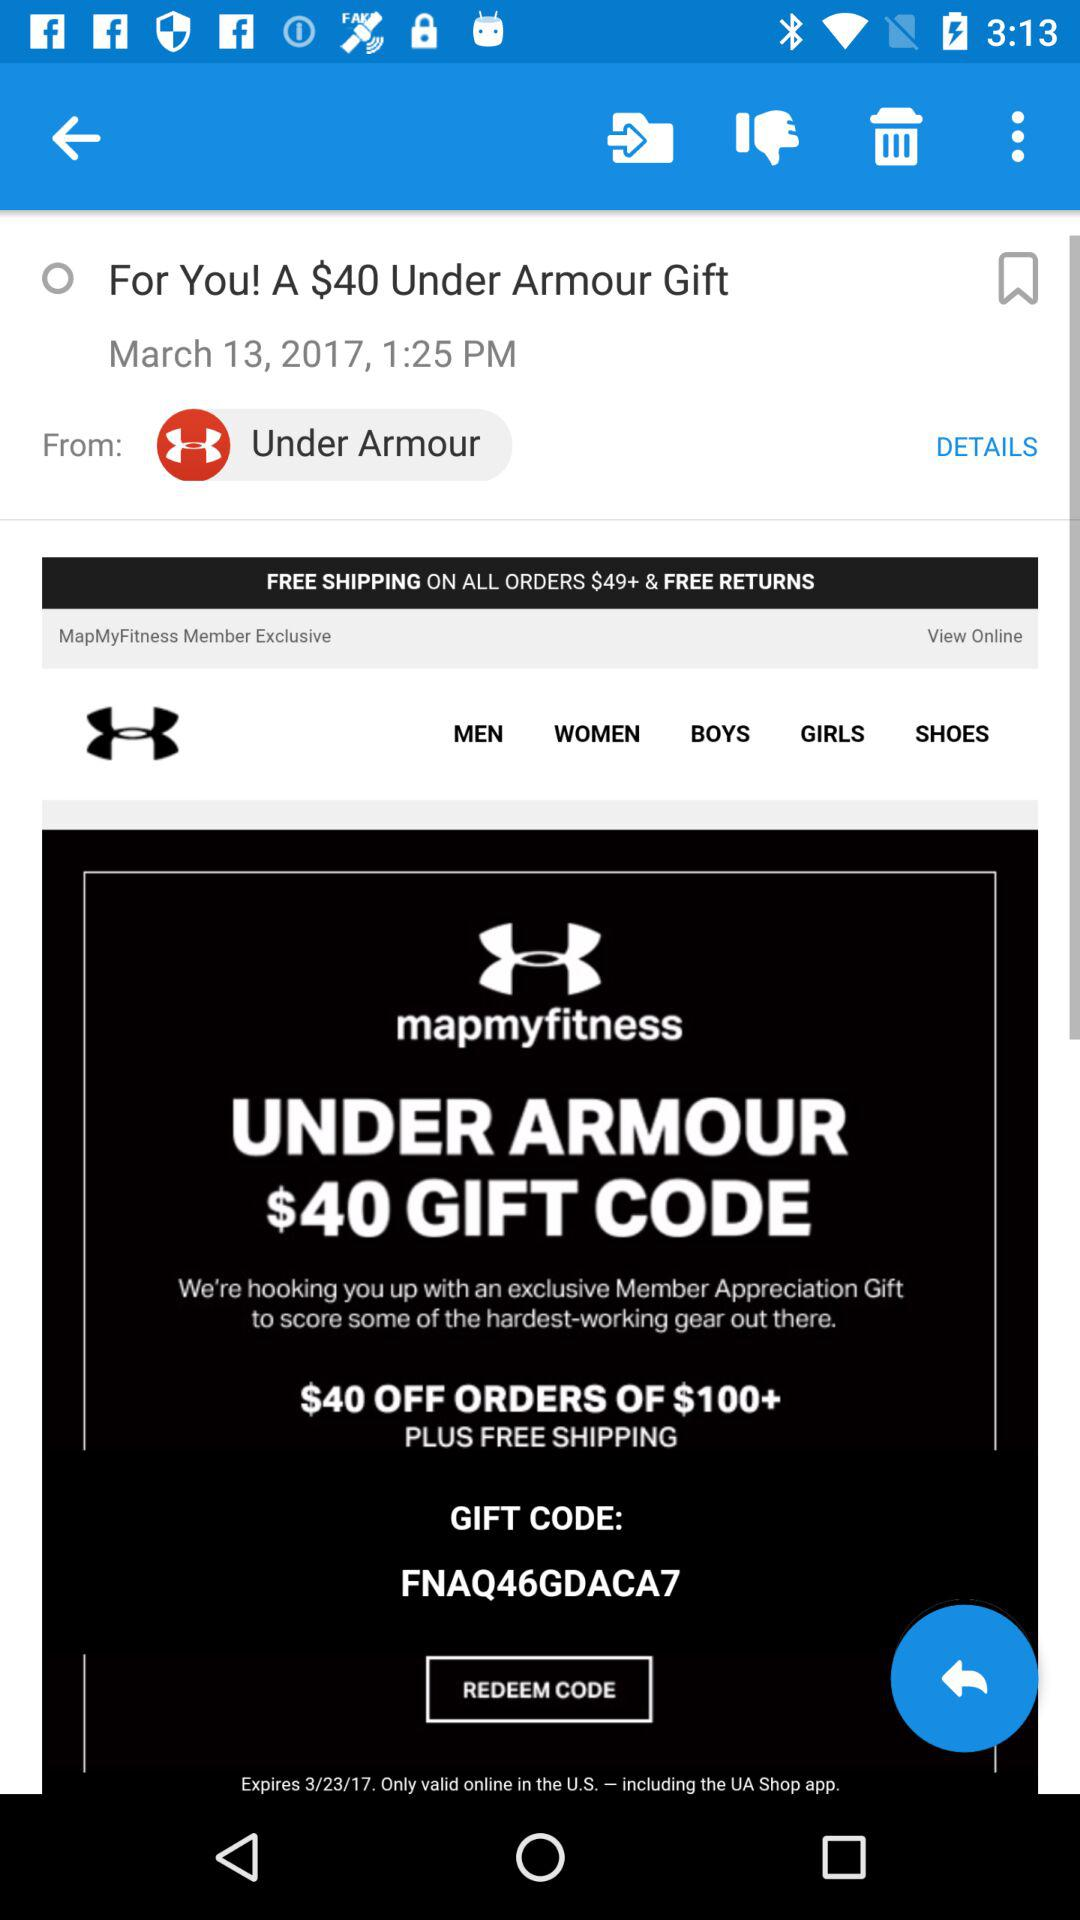What information is provided in "DETAILS"?
When the provided information is insufficient, respond with <no answer>. <no answer> 